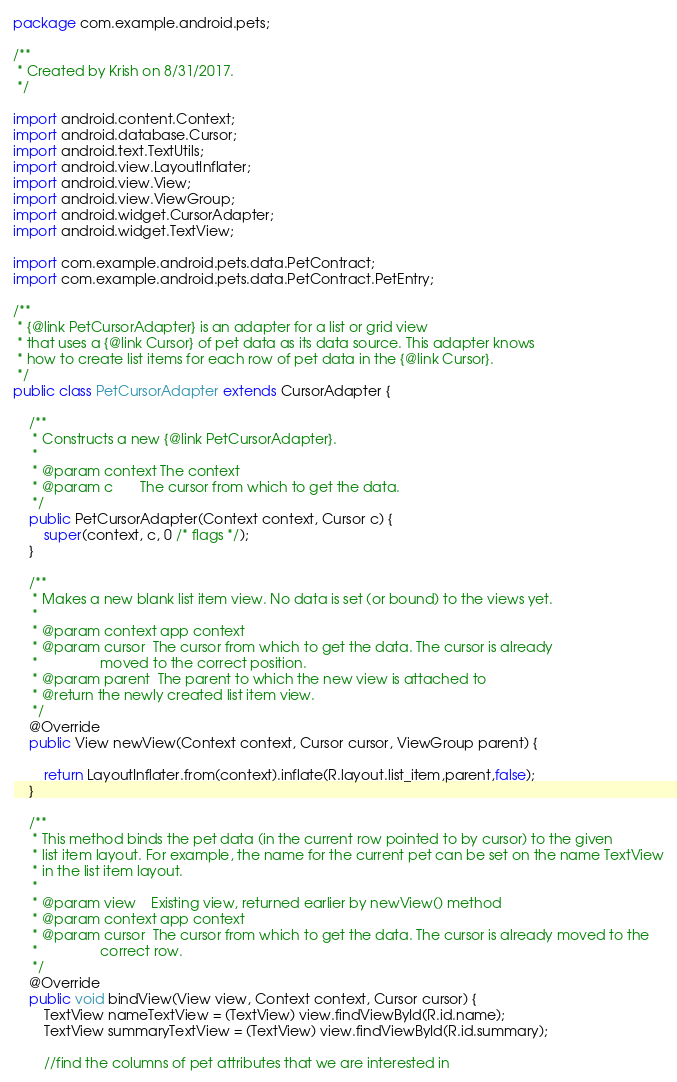Convert code to text. <code><loc_0><loc_0><loc_500><loc_500><_Java_>package com.example.android.pets;

/**
 * Created by Krish on 8/31/2017.
 */

import android.content.Context;
import android.database.Cursor;
import android.text.TextUtils;
import android.view.LayoutInflater;
import android.view.View;
import android.view.ViewGroup;
import android.widget.CursorAdapter;
import android.widget.TextView;

import com.example.android.pets.data.PetContract;
import com.example.android.pets.data.PetContract.PetEntry;

/**
 * {@link PetCursorAdapter} is an adapter for a list or grid view
 * that uses a {@link Cursor} of pet data as its data source. This adapter knows
 * how to create list items for each row of pet data in the {@link Cursor}.
 */
public class PetCursorAdapter extends CursorAdapter {

    /**
     * Constructs a new {@link PetCursorAdapter}.
     *
     * @param context The context
     * @param c       The cursor from which to get the data.
     */
    public PetCursorAdapter(Context context, Cursor c) {
        super(context, c, 0 /* flags */);
    }

    /**
     * Makes a new blank list item view. No data is set (or bound) to the views yet.
     *
     * @param context app context
     * @param cursor  The cursor from which to get the data. The cursor is already
     *                moved to the correct position.
     * @param parent  The parent to which the new view is attached to
     * @return the newly created list item view.
     */
    @Override
    public View newView(Context context, Cursor cursor, ViewGroup parent) {

        return LayoutInflater.from(context).inflate(R.layout.list_item,parent,false);
    }

    /**
     * This method binds the pet data (in the current row pointed to by cursor) to the given
     * list item layout. For example, the name for the current pet can be set on the name TextView
     * in the list item layout.
     *
     * @param view    Existing view, returned earlier by newView() method
     * @param context app context
     * @param cursor  The cursor from which to get the data. The cursor is already moved to the
     *                correct row.
     */
    @Override
    public void bindView(View view, Context context, Cursor cursor) {
        TextView nameTextView = (TextView) view.findViewById(R.id.name);
        TextView summaryTextView = (TextView) view.findViewById(R.id.summary);

        //find the columns of pet attributes that we are interested in</code> 